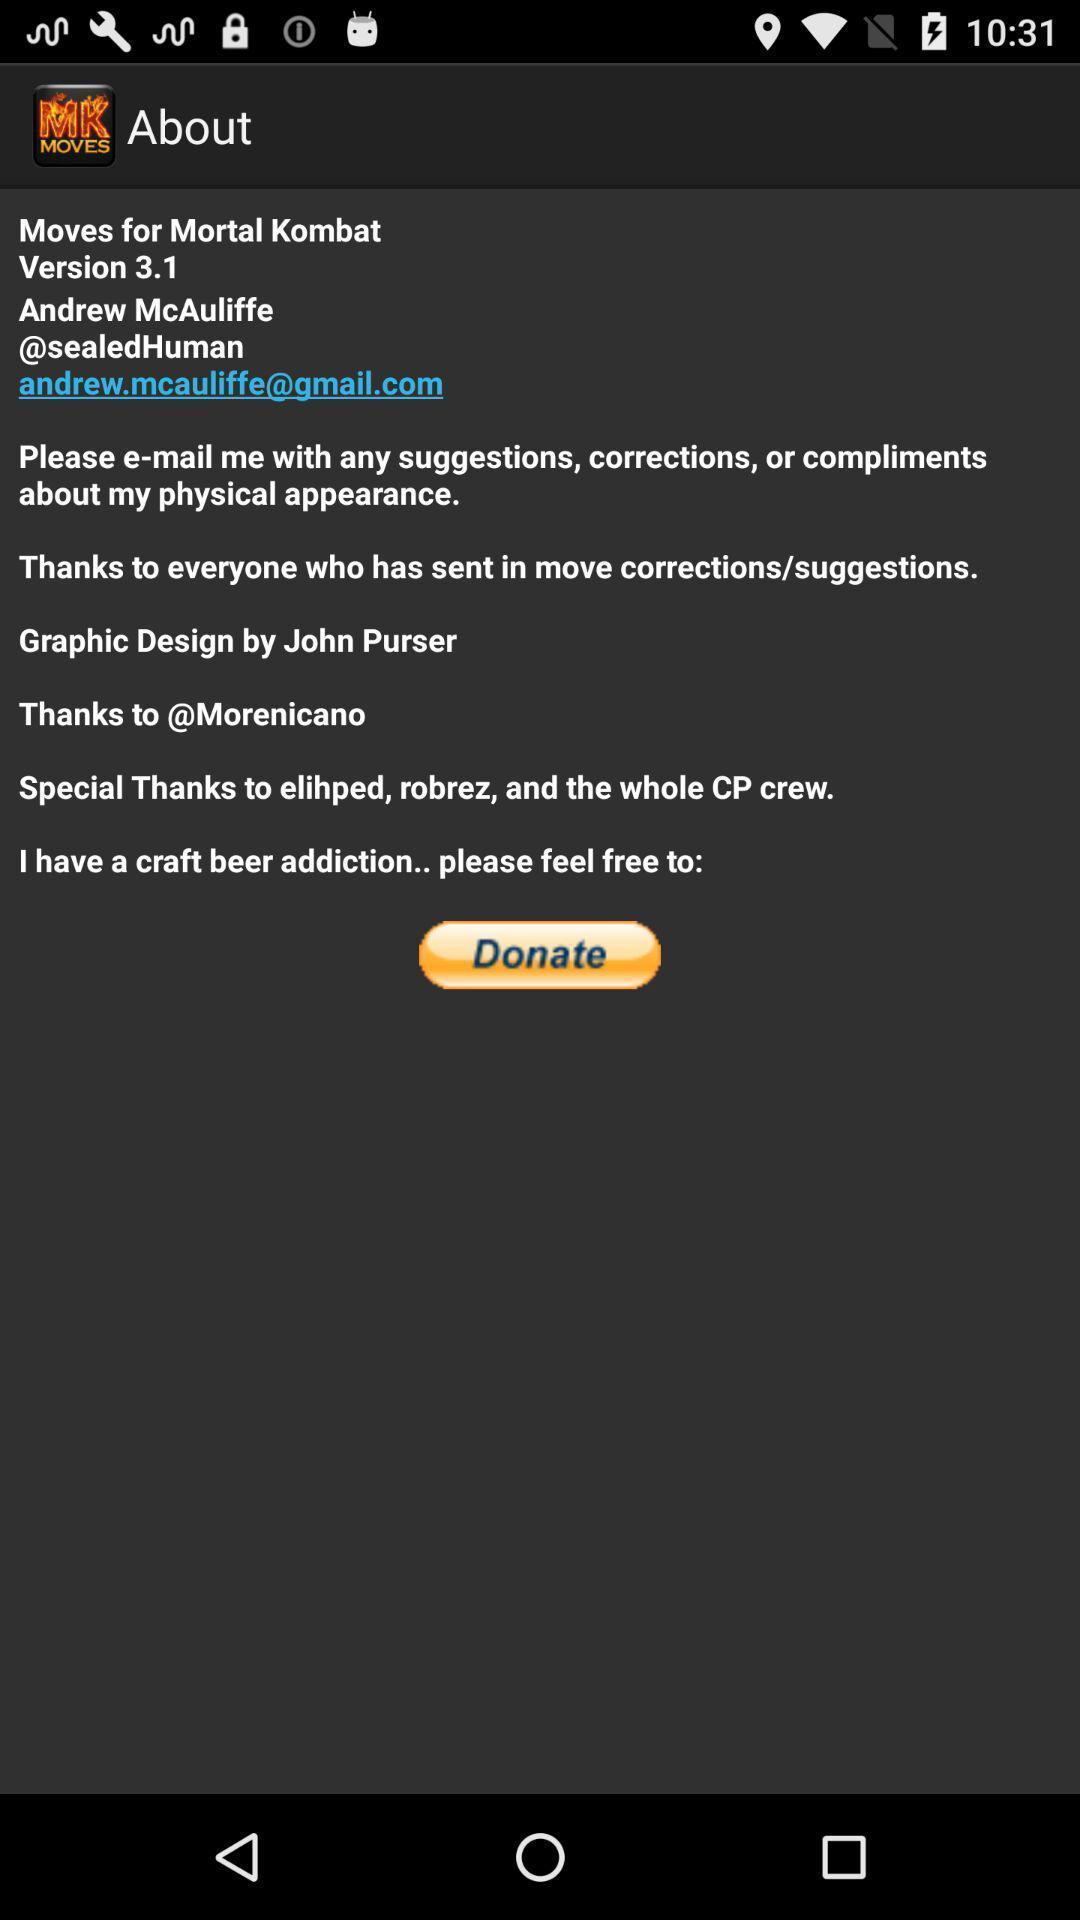Please provide a description for this image. Page showing information like version. 